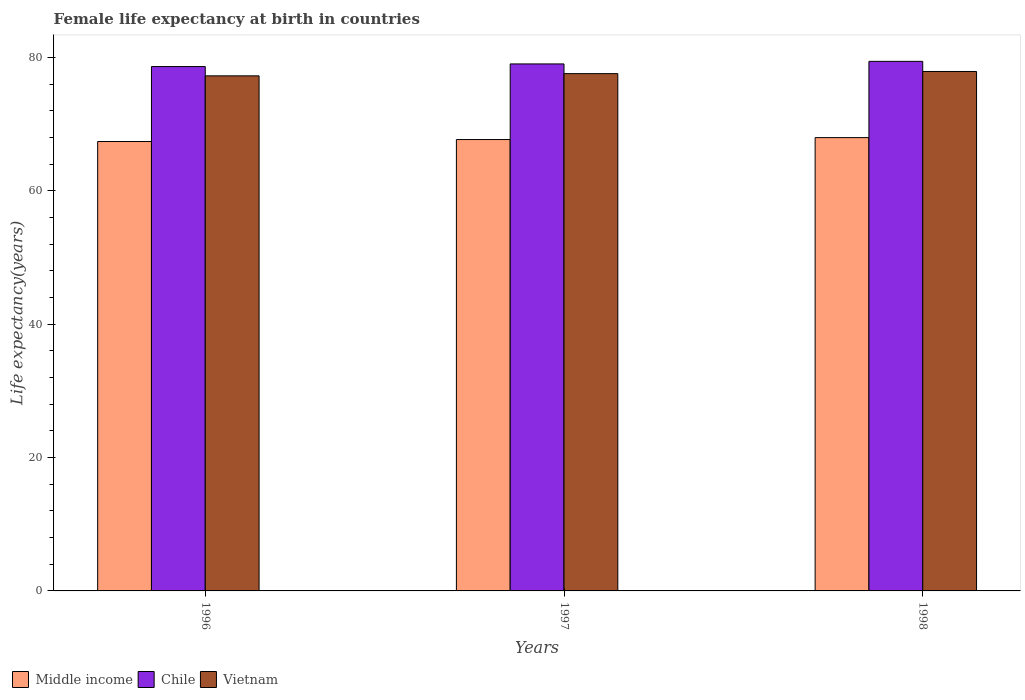How many groups of bars are there?
Provide a succinct answer. 3. What is the female life expectancy at birth in Middle income in 1997?
Provide a short and direct response. 67.68. Across all years, what is the maximum female life expectancy at birth in Vietnam?
Your answer should be compact. 77.88. Across all years, what is the minimum female life expectancy at birth in Vietnam?
Your answer should be very brief. 77.22. In which year was the female life expectancy at birth in Chile minimum?
Your answer should be very brief. 1996. What is the total female life expectancy at birth in Vietnam in the graph?
Your answer should be compact. 232.66. What is the difference between the female life expectancy at birth in Vietnam in 1997 and that in 1998?
Offer a very short reply. -0.32. What is the difference between the female life expectancy at birth in Middle income in 1997 and the female life expectancy at birth in Chile in 1996?
Make the answer very short. -10.94. What is the average female life expectancy at birth in Middle income per year?
Your answer should be compact. 67.67. In the year 1997, what is the difference between the female life expectancy at birth in Chile and female life expectancy at birth in Vietnam?
Keep it short and to the point. 1.45. What is the ratio of the female life expectancy at birth in Vietnam in 1996 to that in 1998?
Your answer should be very brief. 0.99. Is the female life expectancy at birth in Middle income in 1996 less than that in 1998?
Give a very brief answer. Yes. What is the difference between the highest and the second highest female life expectancy at birth in Chile?
Provide a succinct answer. 0.39. What is the difference between the highest and the lowest female life expectancy at birth in Vietnam?
Your answer should be compact. 0.66. In how many years, is the female life expectancy at birth in Chile greater than the average female life expectancy at birth in Chile taken over all years?
Offer a very short reply. 2. Are all the bars in the graph horizontal?
Your answer should be compact. No. What is the difference between two consecutive major ticks on the Y-axis?
Keep it short and to the point. 20. Does the graph contain grids?
Offer a terse response. No. Where does the legend appear in the graph?
Give a very brief answer. Bottom left. How are the legend labels stacked?
Keep it short and to the point. Horizontal. What is the title of the graph?
Your answer should be compact. Female life expectancy at birth in countries. Does "Sweden" appear as one of the legend labels in the graph?
Provide a short and direct response. No. What is the label or title of the Y-axis?
Make the answer very short. Life expectancy(years). What is the Life expectancy(years) of Middle income in 1996?
Make the answer very short. 67.38. What is the Life expectancy(years) in Chile in 1996?
Keep it short and to the point. 78.62. What is the Life expectancy(years) of Vietnam in 1996?
Your answer should be very brief. 77.22. What is the Life expectancy(years) of Middle income in 1997?
Your answer should be compact. 67.68. What is the Life expectancy(years) of Chile in 1997?
Give a very brief answer. 79.01. What is the Life expectancy(years) of Vietnam in 1997?
Offer a very short reply. 77.56. What is the Life expectancy(years) of Middle income in 1998?
Provide a short and direct response. 67.96. What is the Life expectancy(years) of Chile in 1998?
Provide a short and direct response. 79.4. What is the Life expectancy(years) in Vietnam in 1998?
Provide a succinct answer. 77.88. Across all years, what is the maximum Life expectancy(years) of Middle income?
Keep it short and to the point. 67.96. Across all years, what is the maximum Life expectancy(years) in Chile?
Provide a short and direct response. 79.4. Across all years, what is the maximum Life expectancy(years) in Vietnam?
Offer a terse response. 77.88. Across all years, what is the minimum Life expectancy(years) of Middle income?
Provide a short and direct response. 67.38. Across all years, what is the minimum Life expectancy(years) of Chile?
Offer a terse response. 78.62. Across all years, what is the minimum Life expectancy(years) in Vietnam?
Provide a short and direct response. 77.22. What is the total Life expectancy(years) in Middle income in the graph?
Keep it short and to the point. 203.02. What is the total Life expectancy(years) of Chile in the graph?
Provide a short and direct response. 237.03. What is the total Life expectancy(years) in Vietnam in the graph?
Your answer should be very brief. 232.66. What is the difference between the Life expectancy(years) of Middle income in 1996 and that in 1997?
Offer a terse response. -0.3. What is the difference between the Life expectancy(years) of Chile in 1996 and that in 1997?
Make the answer very short. -0.39. What is the difference between the Life expectancy(years) of Vietnam in 1996 and that in 1997?
Your answer should be compact. -0.33. What is the difference between the Life expectancy(years) of Middle income in 1996 and that in 1998?
Provide a succinct answer. -0.59. What is the difference between the Life expectancy(years) of Chile in 1996 and that in 1998?
Give a very brief answer. -0.78. What is the difference between the Life expectancy(years) of Vietnam in 1996 and that in 1998?
Your answer should be very brief. -0.66. What is the difference between the Life expectancy(years) in Middle income in 1997 and that in 1998?
Your answer should be very brief. -0.29. What is the difference between the Life expectancy(years) in Chile in 1997 and that in 1998?
Keep it short and to the point. -0.39. What is the difference between the Life expectancy(years) in Vietnam in 1997 and that in 1998?
Provide a short and direct response. -0.32. What is the difference between the Life expectancy(years) in Middle income in 1996 and the Life expectancy(years) in Chile in 1997?
Your response must be concise. -11.63. What is the difference between the Life expectancy(years) in Middle income in 1996 and the Life expectancy(years) in Vietnam in 1997?
Your response must be concise. -10.18. What is the difference between the Life expectancy(years) of Chile in 1996 and the Life expectancy(years) of Vietnam in 1997?
Your response must be concise. 1.06. What is the difference between the Life expectancy(years) in Middle income in 1996 and the Life expectancy(years) in Chile in 1998?
Keep it short and to the point. -12.02. What is the difference between the Life expectancy(years) of Middle income in 1996 and the Life expectancy(years) of Vietnam in 1998?
Your answer should be very brief. -10.5. What is the difference between the Life expectancy(years) of Chile in 1996 and the Life expectancy(years) of Vietnam in 1998?
Keep it short and to the point. 0.74. What is the difference between the Life expectancy(years) in Middle income in 1997 and the Life expectancy(years) in Chile in 1998?
Offer a very short reply. -11.72. What is the difference between the Life expectancy(years) in Middle income in 1997 and the Life expectancy(years) in Vietnam in 1998?
Ensure brevity in your answer.  -10.2. What is the difference between the Life expectancy(years) in Chile in 1997 and the Life expectancy(years) in Vietnam in 1998?
Your answer should be compact. 1.13. What is the average Life expectancy(years) of Middle income per year?
Give a very brief answer. 67.67. What is the average Life expectancy(years) of Chile per year?
Offer a very short reply. 79.01. What is the average Life expectancy(years) of Vietnam per year?
Your answer should be compact. 77.55. In the year 1996, what is the difference between the Life expectancy(years) of Middle income and Life expectancy(years) of Chile?
Keep it short and to the point. -11.24. In the year 1996, what is the difference between the Life expectancy(years) of Middle income and Life expectancy(years) of Vietnam?
Ensure brevity in your answer.  -9.85. In the year 1996, what is the difference between the Life expectancy(years) of Chile and Life expectancy(years) of Vietnam?
Your answer should be compact. 1.39. In the year 1997, what is the difference between the Life expectancy(years) in Middle income and Life expectancy(years) in Chile?
Provide a succinct answer. -11.34. In the year 1997, what is the difference between the Life expectancy(years) in Middle income and Life expectancy(years) in Vietnam?
Your answer should be compact. -9.88. In the year 1997, what is the difference between the Life expectancy(years) of Chile and Life expectancy(years) of Vietnam?
Make the answer very short. 1.45. In the year 1998, what is the difference between the Life expectancy(years) in Middle income and Life expectancy(years) in Chile?
Make the answer very short. -11.43. In the year 1998, what is the difference between the Life expectancy(years) of Middle income and Life expectancy(years) of Vietnam?
Your response must be concise. -9.92. In the year 1998, what is the difference between the Life expectancy(years) of Chile and Life expectancy(years) of Vietnam?
Offer a very short reply. 1.52. What is the ratio of the Life expectancy(years) in Middle income in 1996 to that in 1998?
Offer a terse response. 0.99. What is the ratio of the Life expectancy(years) of Chile in 1996 to that in 1998?
Provide a succinct answer. 0.99. What is the ratio of the Life expectancy(years) in Vietnam in 1996 to that in 1998?
Provide a short and direct response. 0.99. What is the ratio of the Life expectancy(years) in Middle income in 1997 to that in 1998?
Ensure brevity in your answer.  1. What is the difference between the highest and the second highest Life expectancy(years) of Middle income?
Your response must be concise. 0.29. What is the difference between the highest and the second highest Life expectancy(years) in Chile?
Give a very brief answer. 0.39. What is the difference between the highest and the second highest Life expectancy(years) of Vietnam?
Give a very brief answer. 0.32. What is the difference between the highest and the lowest Life expectancy(years) in Middle income?
Your answer should be compact. 0.59. What is the difference between the highest and the lowest Life expectancy(years) in Chile?
Offer a very short reply. 0.78. What is the difference between the highest and the lowest Life expectancy(years) in Vietnam?
Provide a short and direct response. 0.66. 